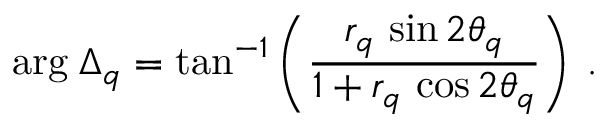Convert formula to latex. <formula><loc_0><loc_0><loc_500><loc_500>\arg \, \Delta _ { q } = t a n ^ { - 1 } \left ( \frac { r _ { q } \, \sin 2 \theta _ { q } } { 1 + r _ { q } \, \cos 2 \theta _ { q } } \right ) \, .</formula> 